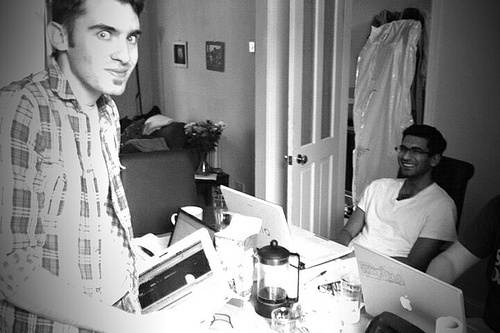Describe the objects in this image and their specific colors. I can see people in black, darkgray, gainsboro, and gray tones, people in black, lightgray, darkgray, and gray tones, laptop in black, darkgray, gray, and lightgray tones, couch in black, gray, darkgray, and lightgray tones, and laptop in black, white, darkgray, and gray tones in this image. 